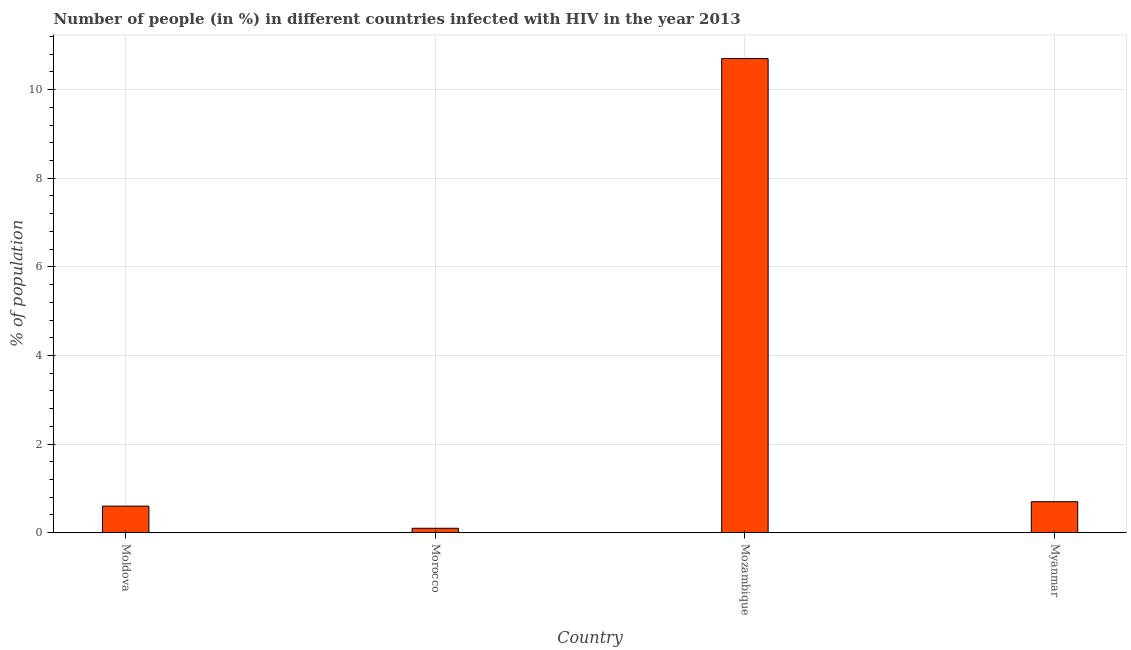Does the graph contain any zero values?
Your answer should be compact. No. Does the graph contain grids?
Provide a short and direct response. Yes. What is the title of the graph?
Give a very brief answer. Number of people (in %) in different countries infected with HIV in the year 2013. What is the label or title of the X-axis?
Your answer should be compact. Country. What is the label or title of the Y-axis?
Keep it short and to the point. % of population. What is the number of people infected with hiv in Moldova?
Give a very brief answer. 0.6. In which country was the number of people infected with hiv maximum?
Offer a very short reply. Mozambique. In which country was the number of people infected with hiv minimum?
Make the answer very short. Morocco. What is the sum of the number of people infected with hiv?
Your response must be concise. 12.1. What is the difference between the number of people infected with hiv in Mozambique and Myanmar?
Provide a succinct answer. 10. What is the average number of people infected with hiv per country?
Your answer should be very brief. 3.02. What is the median number of people infected with hiv?
Offer a terse response. 0.65. In how many countries, is the number of people infected with hiv greater than 9.2 %?
Your answer should be very brief. 1. What is the ratio of the number of people infected with hiv in Moldova to that in Myanmar?
Provide a succinct answer. 0.86. What is the difference between the highest and the second highest number of people infected with hiv?
Offer a very short reply. 10. Is the sum of the number of people infected with hiv in Moldova and Morocco greater than the maximum number of people infected with hiv across all countries?
Provide a succinct answer. No. How many bars are there?
Give a very brief answer. 4. Are all the bars in the graph horizontal?
Offer a terse response. No. How many countries are there in the graph?
Ensure brevity in your answer.  4. Are the values on the major ticks of Y-axis written in scientific E-notation?
Ensure brevity in your answer.  No. What is the % of population of Moldova?
Your answer should be very brief. 0.6. What is the % of population of Morocco?
Offer a terse response. 0.1. What is the % of population in Mozambique?
Provide a succinct answer. 10.7. What is the % of population in Myanmar?
Make the answer very short. 0.7. What is the difference between the % of population in Morocco and Mozambique?
Ensure brevity in your answer.  -10.6. What is the difference between the % of population in Morocco and Myanmar?
Provide a short and direct response. -0.6. What is the difference between the % of population in Mozambique and Myanmar?
Offer a very short reply. 10. What is the ratio of the % of population in Moldova to that in Mozambique?
Give a very brief answer. 0.06. What is the ratio of the % of population in Moldova to that in Myanmar?
Your response must be concise. 0.86. What is the ratio of the % of population in Morocco to that in Mozambique?
Give a very brief answer. 0.01. What is the ratio of the % of population in Morocco to that in Myanmar?
Make the answer very short. 0.14. What is the ratio of the % of population in Mozambique to that in Myanmar?
Offer a terse response. 15.29. 